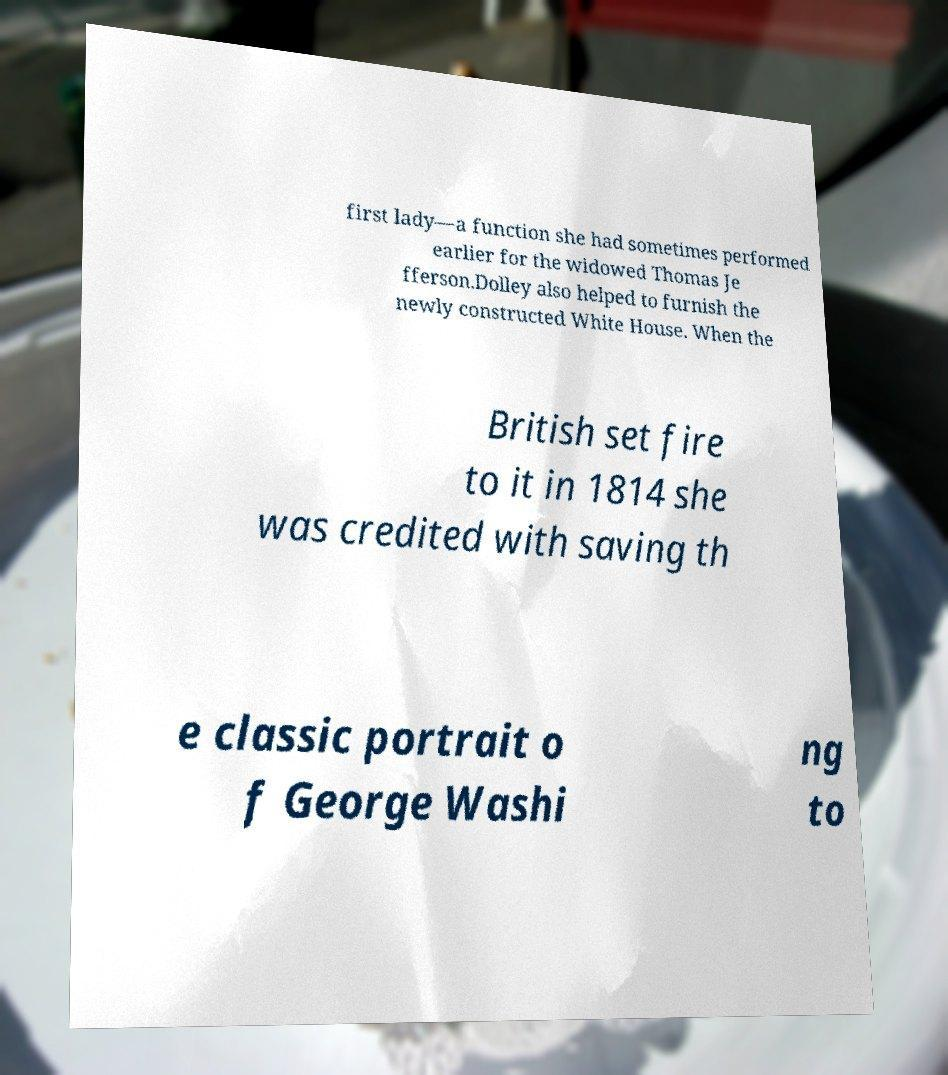There's text embedded in this image that I need extracted. Can you transcribe it verbatim? first lady—a function she had sometimes performed earlier for the widowed Thomas Je fferson.Dolley also helped to furnish the newly constructed White House. When the British set fire to it in 1814 she was credited with saving th e classic portrait o f George Washi ng to 